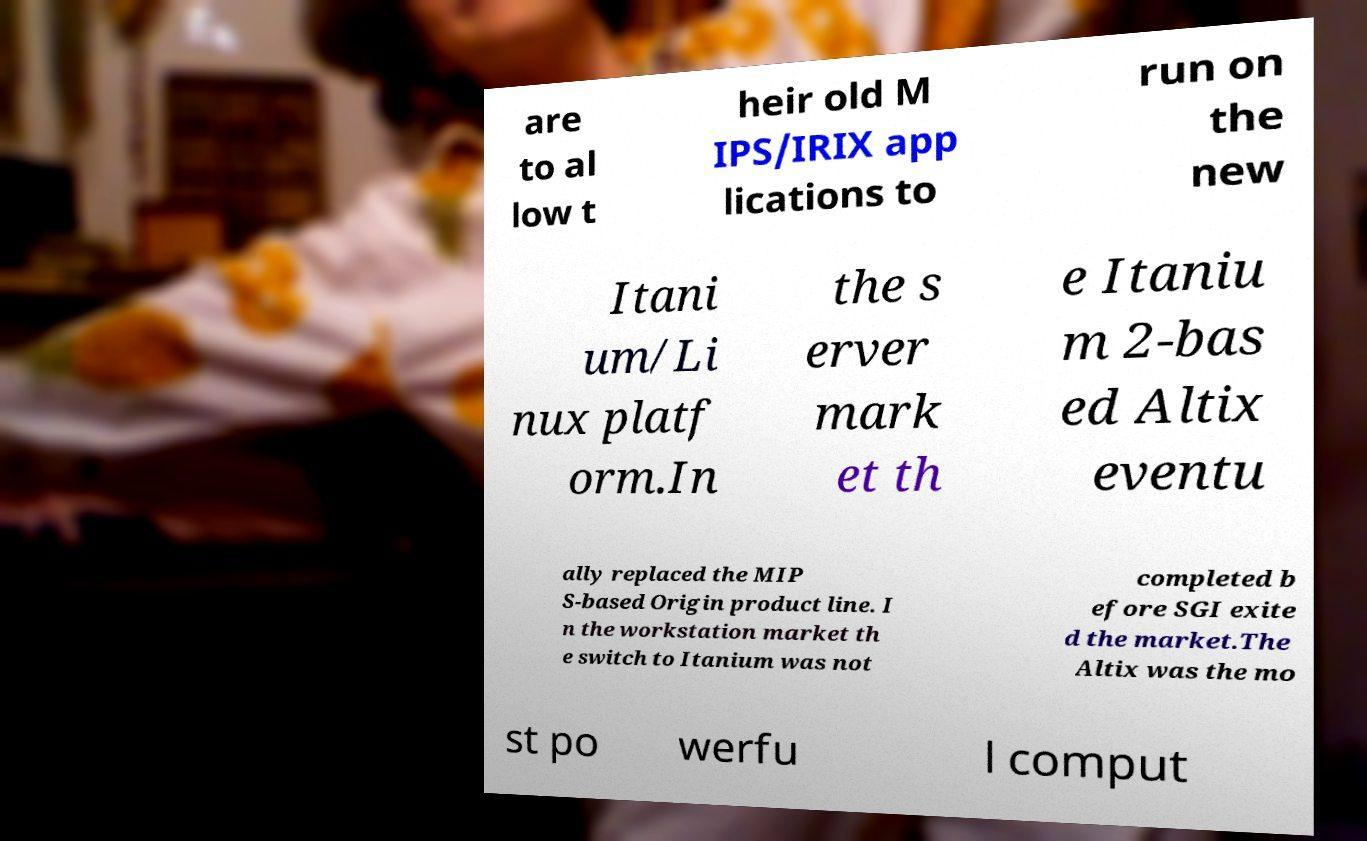Can you accurately transcribe the text from the provided image for me? are to al low t heir old M IPS/IRIX app lications to run on the new Itani um/Li nux platf orm.In the s erver mark et th e Itaniu m 2-bas ed Altix eventu ally replaced the MIP S-based Origin product line. I n the workstation market th e switch to Itanium was not completed b efore SGI exite d the market.The Altix was the mo st po werfu l comput 